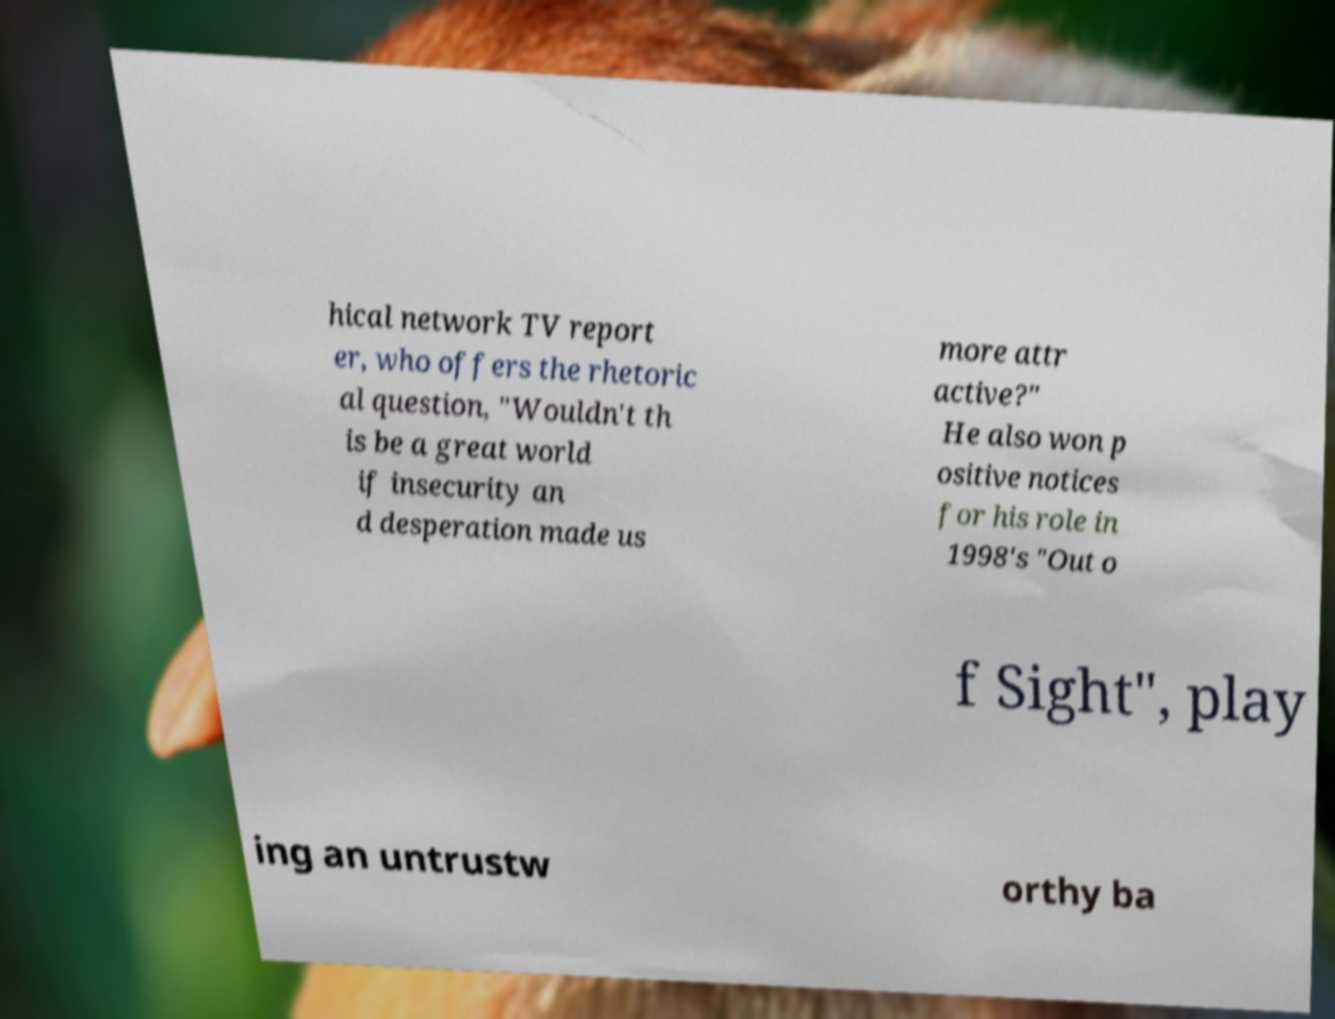Can you read and provide the text displayed in the image?This photo seems to have some interesting text. Can you extract and type it out for me? hical network TV report er, who offers the rhetoric al question, "Wouldn't th is be a great world if insecurity an d desperation made us more attr active?" He also won p ositive notices for his role in 1998's "Out o f Sight", play ing an untrustw orthy ba 